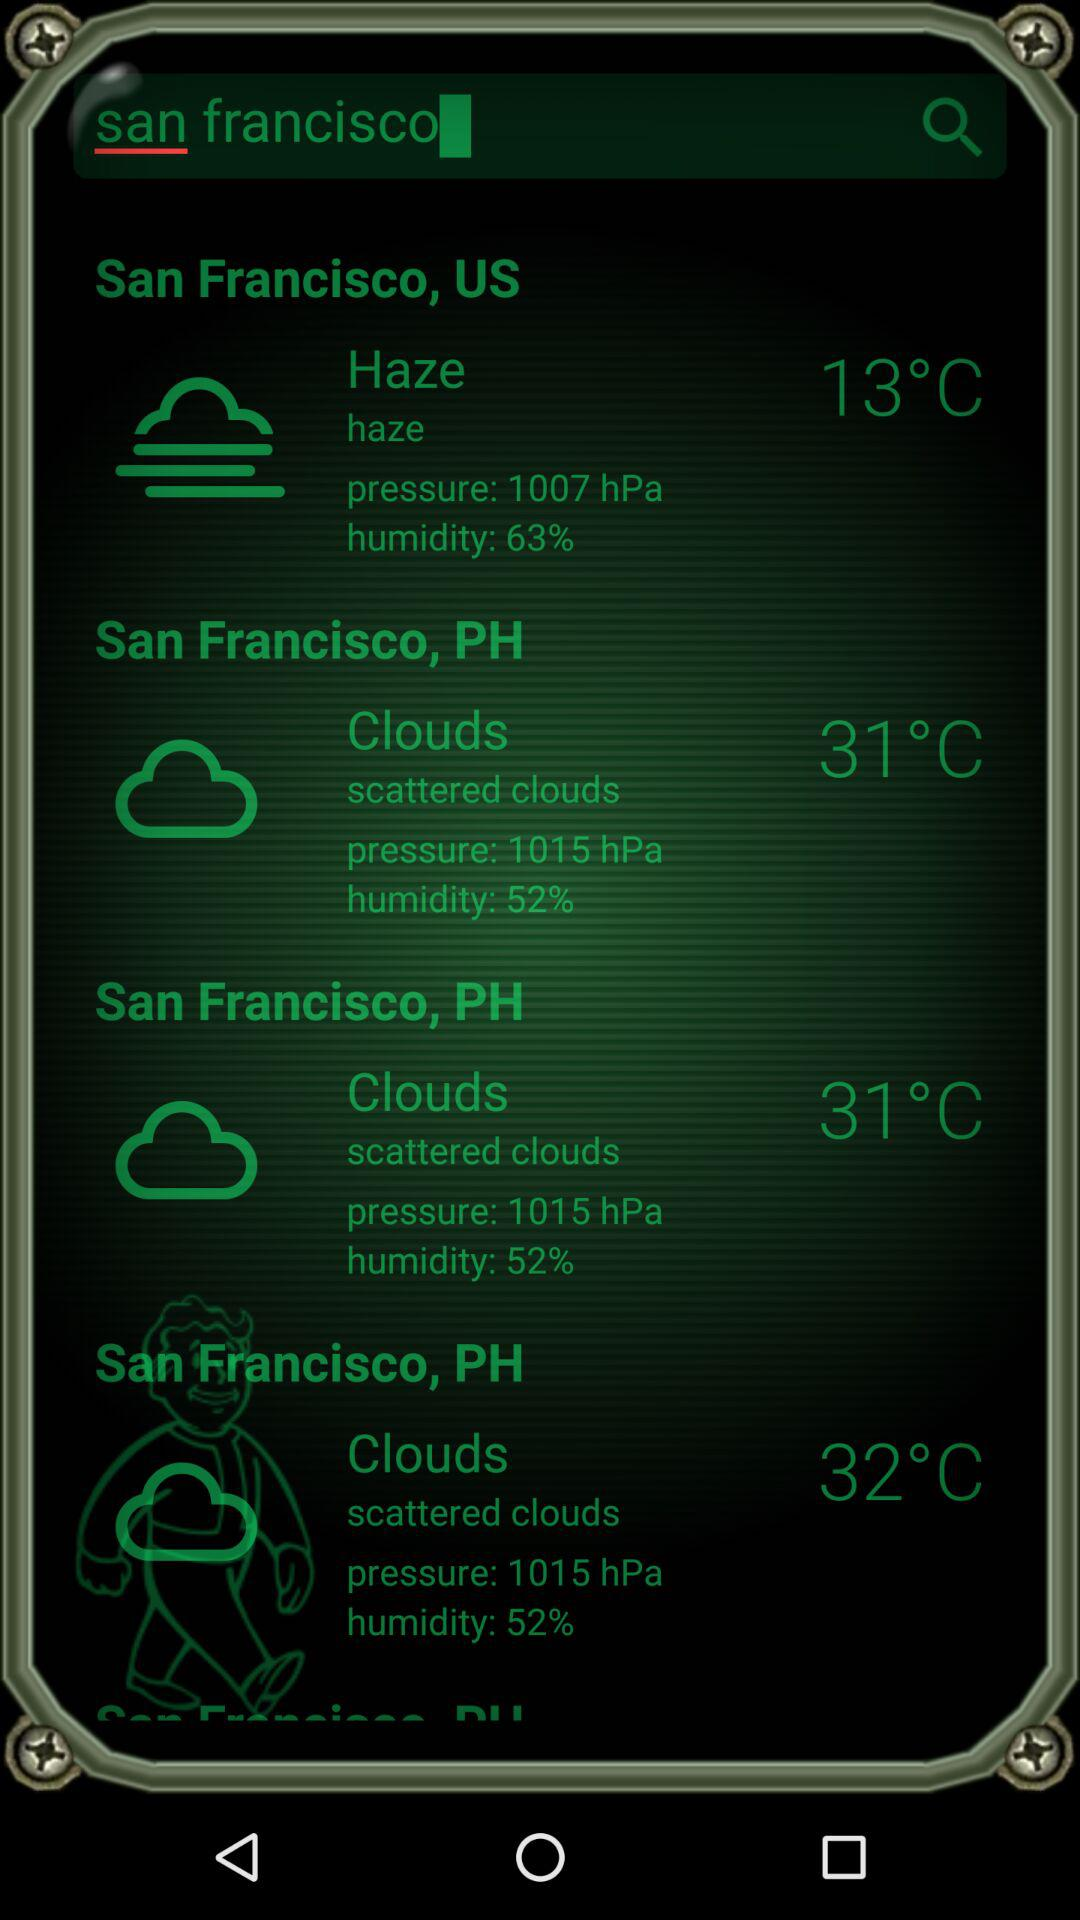What is the temperature of the "Haze"? The temperature is 13°C. 